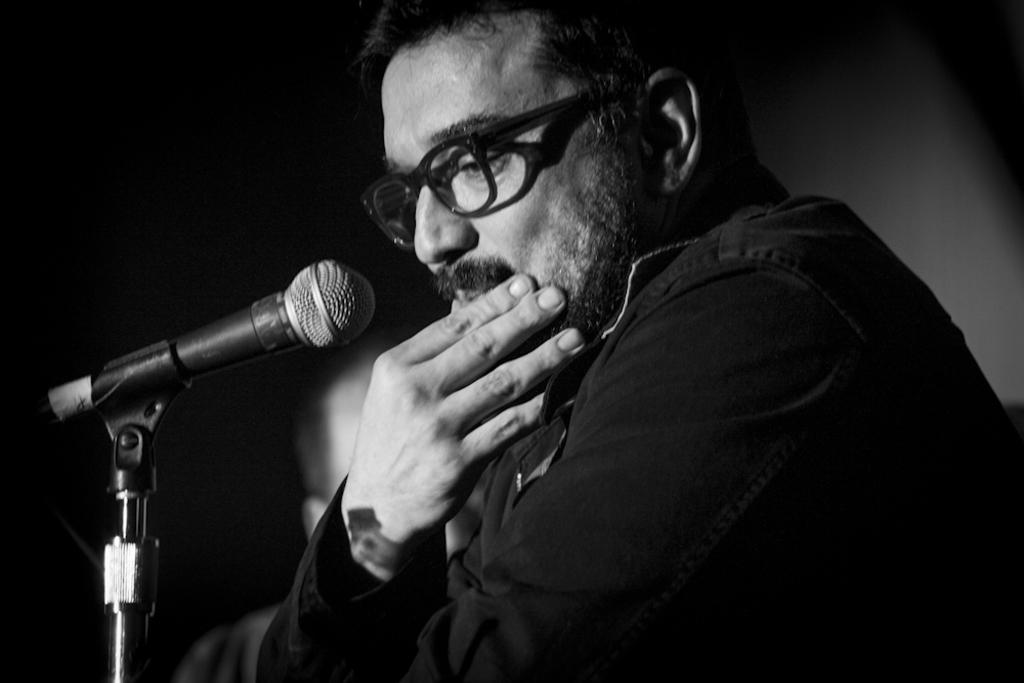How many people are in the image? There are two persons in the image. Where are the two persons located in the image? The two persons are in the middle of the image. What object can be seen on the left side of the image? There is a microphone (Mic) on the left side of the image. What type of care can be seen being provided to the persons in the image? There is no indication of care being provided in the image; it simply shows two persons and a microphone. 